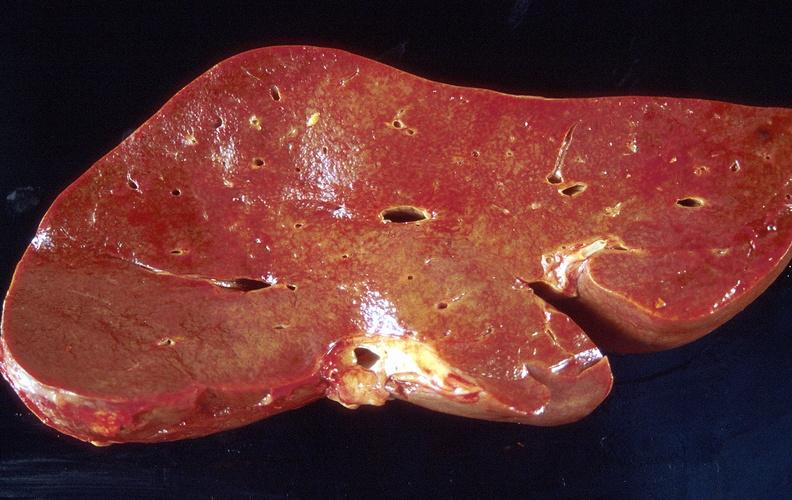s anencephaly present?
Answer the question using a single word or phrase. No 